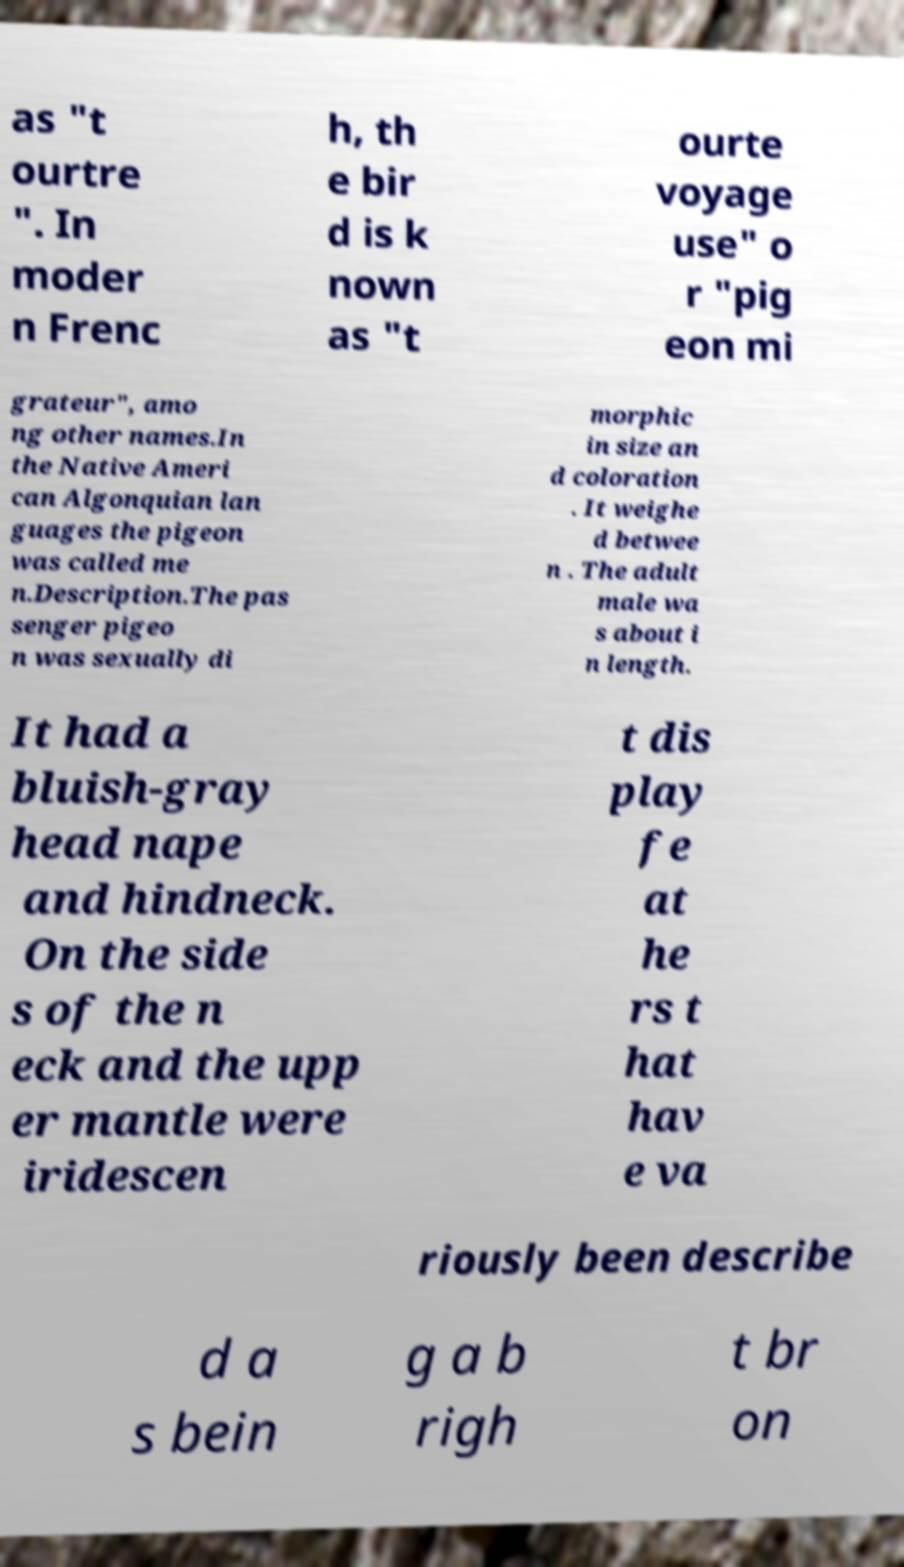What messages or text are displayed in this image? I need them in a readable, typed format. as "t ourtre ". In moder n Frenc h, th e bir d is k nown as "t ourte voyage use" o r "pig eon mi grateur", amo ng other names.In the Native Ameri can Algonquian lan guages the pigeon was called me n.Description.The pas senger pigeo n was sexually di morphic in size an d coloration . It weighe d betwee n . The adult male wa s about i n length. It had a bluish-gray head nape and hindneck. On the side s of the n eck and the upp er mantle were iridescen t dis play fe at he rs t hat hav e va riously been describe d a s bein g a b righ t br on 